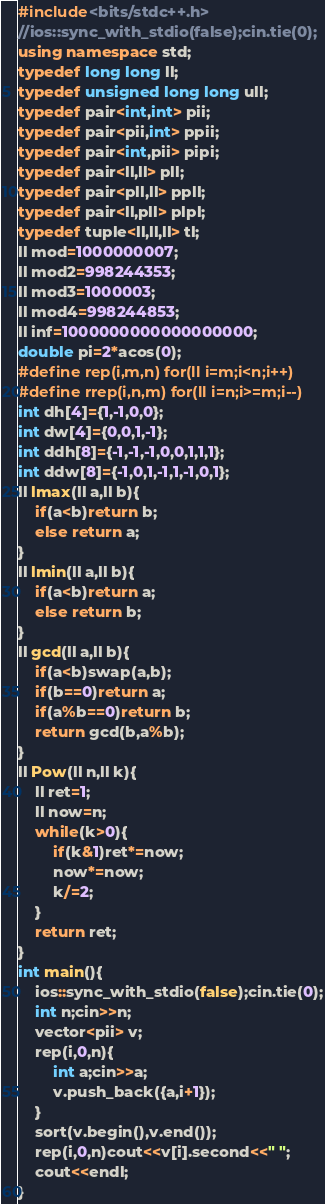<code> <loc_0><loc_0><loc_500><loc_500><_C++_>#include<bits/stdc++.h>
//ios::sync_with_stdio(false);cin.tie(0);
using namespace std;
typedef long long ll;
typedef unsigned long long ull;
typedef pair<int,int> pii;
typedef pair<pii,int> ppii;
typedef pair<int,pii> pipi;
typedef pair<ll,ll> pll;
typedef pair<pll,ll> ppll;
typedef pair<ll,pll> plpl;
typedef tuple<ll,ll,ll> tl;
ll mod=1000000007;
ll mod2=998244353;
ll mod3=1000003;
ll mod4=998244853;
ll inf=1000000000000000000;
double pi=2*acos(0);
#define rep(i,m,n) for(ll i=m;i<n;i++)
#define rrep(i,n,m) for(ll i=n;i>=m;i--)
int dh[4]={1,-1,0,0};
int dw[4]={0,0,1,-1};
int ddh[8]={-1,-1,-1,0,0,1,1,1};
int ddw[8]={-1,0,1,-1,1,-1,0,1};
ll lmax(ll a,ll b){
    if(a<b)return b;
    else return a;
}
ll lmin(ll a,ll b){
    if(a<b)return a;
    else return b;
}
ll gcd(ll a,ll b){
    if(a<b)swap(a,b);
    if(b==0)return a;
    if(a%b==0)return b;
    return gcd(b,a%b);
}
ll Pow(ll n,ll k){
    ll ret=1;
    ll now=n;
    while(k>0){
        if(k&1)ret*=now;
        now*=now;
        k/=2;
    }
    return ret;
}
int main(){
    ios::sync_with_stdio(false);cin.tie(0);
    int n;cin>>n;
    vector<pii> v;
    rep(i,0,n){
        int a;cin>>a;
        v.push_back({a,i+1});
    }
    sort(v.begin(),v.end());
    rep(i,0,n)cout<<v[i].second<<" ";
    cout<<endl;
}
</code> 